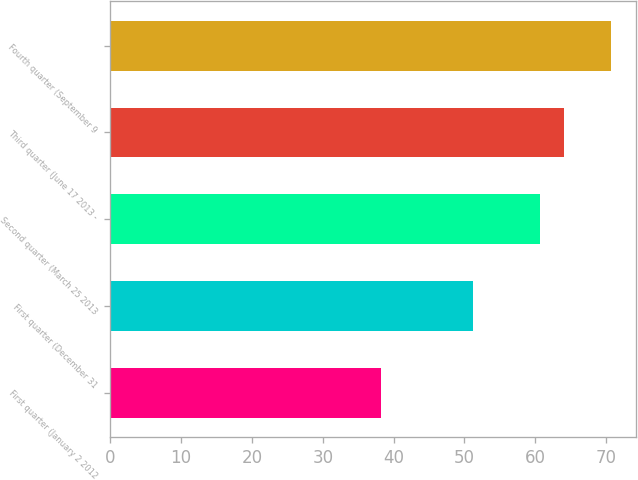Convert chart. <chart><loc_0><loc_0><loc_500><loc_500><bar_chart><fcel>First quarter (January 2 2012<fcel>First quarter (December 31<fcel>Second quarter (March 25 2013<fcel>Third quarter (June 17 2013 -<fcel>Fourth quarter (September 9<nl><fcel>38.22<fcel>51.19<fcel>60.72<fcel>64<fcel>70.68<nl></chart> 